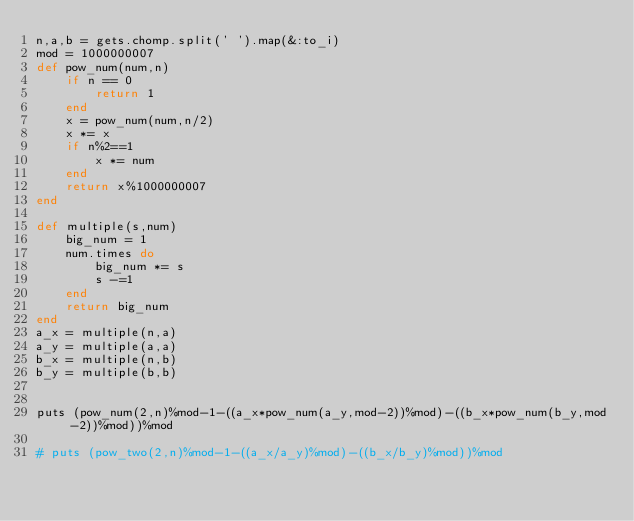Convert code to text. <code><loc_0><loc_0><loc_500><loc_500><_Ruby_>n,a,b = gets.chomp.split(' ').map(&:to_i)
mod = 1000000007
def pow_num(num,n)
    if n == 0
        return 1
    end
    x = pow_num(num,n/2)
    x *= x
    if n%2==1
        x *= num
    end
    return x%1000000007
end

def multiple(s,num)
    big_num = 1
    num.times do
        big_num *= s
        s -=1
    end
    return big_num
end
a_x = multiple(n,a)
a_y = multiple(a,a) 
b_x = multiple(n,b)
b_y = multiple(b,b)


puts (pow_num(2,n)%mod-1-((a_x*pow_num(a_y,mod-2))%mod)-((b_x*pow_num(b_y,mod-2))%mod))%mod

# puts (pow_two(2,n)%mod-1-((a_x/a_y)%mod)-((b_x/b_y)%mod))%mod</code> 